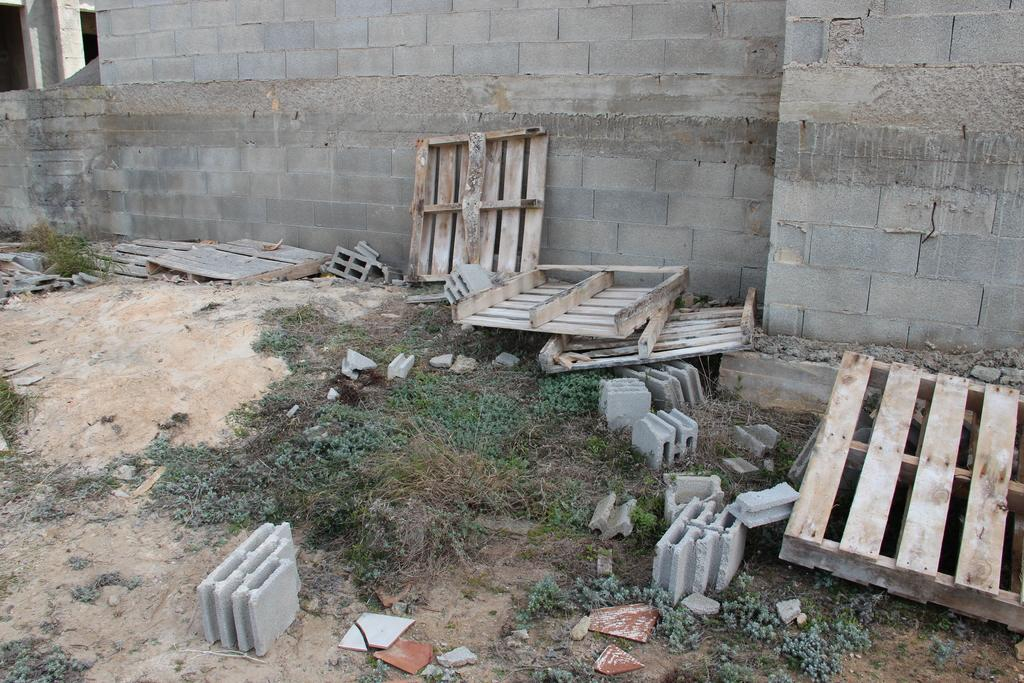What type of material is used to construct the wall in the image? The wall in the image is made of concrete bricks. What other objects can be seen in the image? There are wooden planks and concrete tiles on the ground in the image. What type of sound can be heard coming from the owl in the image? There is no owl present in the image, so it is not possible to determine what sound might be heard. 